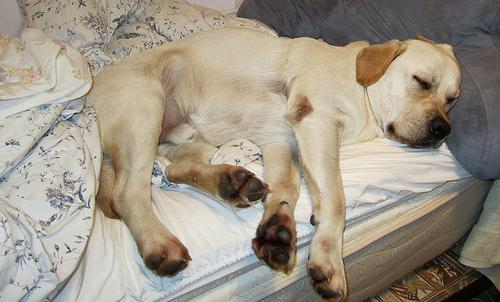Question: what is white and brown?
Choices:
A. Dog.
B. Cow.
C. Rabbit.
D. Horse.
Answer with the letter. Answer: A Question: why is a dog laying down?
Choices:
A. To chew on a bone.
B. To sleep.
C. To play with a toy.
D. To sniff the grass.
Answer with the letter. Answer: B Question: where is the dog?
Choices:
A. In a bed.
B. On the couch.
C. In the dog house.
D. In a kennel.
Answer with the letter. Answer: A Question: who has fallen asleep?
Choices:
A. A dog.
B. A boy.
C. A girl.
D. A cat.
Answer with the letter. Answer: A Question: where is a blanket?
Choices:
A. On the bed.
B. On the floor.
C. On the sofa.
D. On the chair.
Answer with the letter. Answer: A Question: where was the photo taken?
Choices:
A. In a living room.
B. In a bedroom.
C. In a kitchen.
D. In a bathroom.
Answer with the letter. Answer: B 